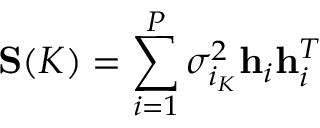<formula> <loc_0><loc_0><loc_500><loc_500>S ( K ) = \sum _ { i = 1 } ^ { P } \sigma _ { i _ { K } } ^ { 2 } h _ { i } h _ { i } ^ { T }</formula> 